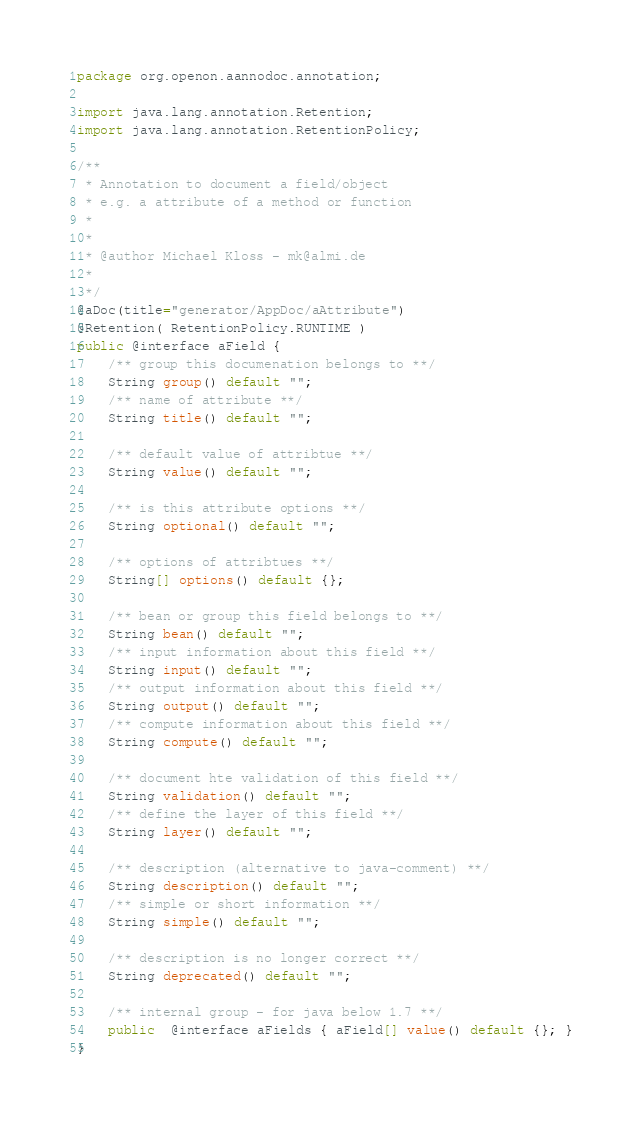<code> <loc_0><loc_0><loc_500><loc_500><_Java_>package org.openon.aannodoc.annotation;

import java.lang.annotation.Retention;
import java.lang.annotation.RetentionPolicy;

/**
 * Annotation to document a field/object
 * e.g. a attribute of a method or function
 * 
 * 
 * @author Michael Kloss - mk@almi.de
 *
 */
@aDoc(title="generator/AppDoc/aAttribute")
@Retention( RetentionPolicy.RUNTIME ) 
public @interface aField {
	/** group this documenation belongs to **/
	String group() default "";
	/** name of attribute **/
	String title() default "";
	 
	/** default value of attribtue **/
	String value() default "";
	
	/** is this attribute options **/
	String optional() default "";
		
	/** options of attribtues **/
	String[] options() default {};
	
	/** bean or group this field belongs to **/
	String bean() default "";
	/** input information about this field **/
	String input() default "";
	/** output information about this field **/
	String output() default "";
	/** compute information about this field **/
	String compute() default "";
	
	/** document hte validation of this field **/
	String validation() default "";
	/** define the layer of this field **/
	String layer() default "";
	
	/** description (alternative to java-comment) **/
	String description() default "";
	/** simple or short information **/
	String simple() default "";
	
	/** description is no longer correct **/
	String deprecated() default ""; 
	
	/** internal group - for java below 1.7 **/
	public  @interface aFields { aField[] value() default {}; }
}
</code> 